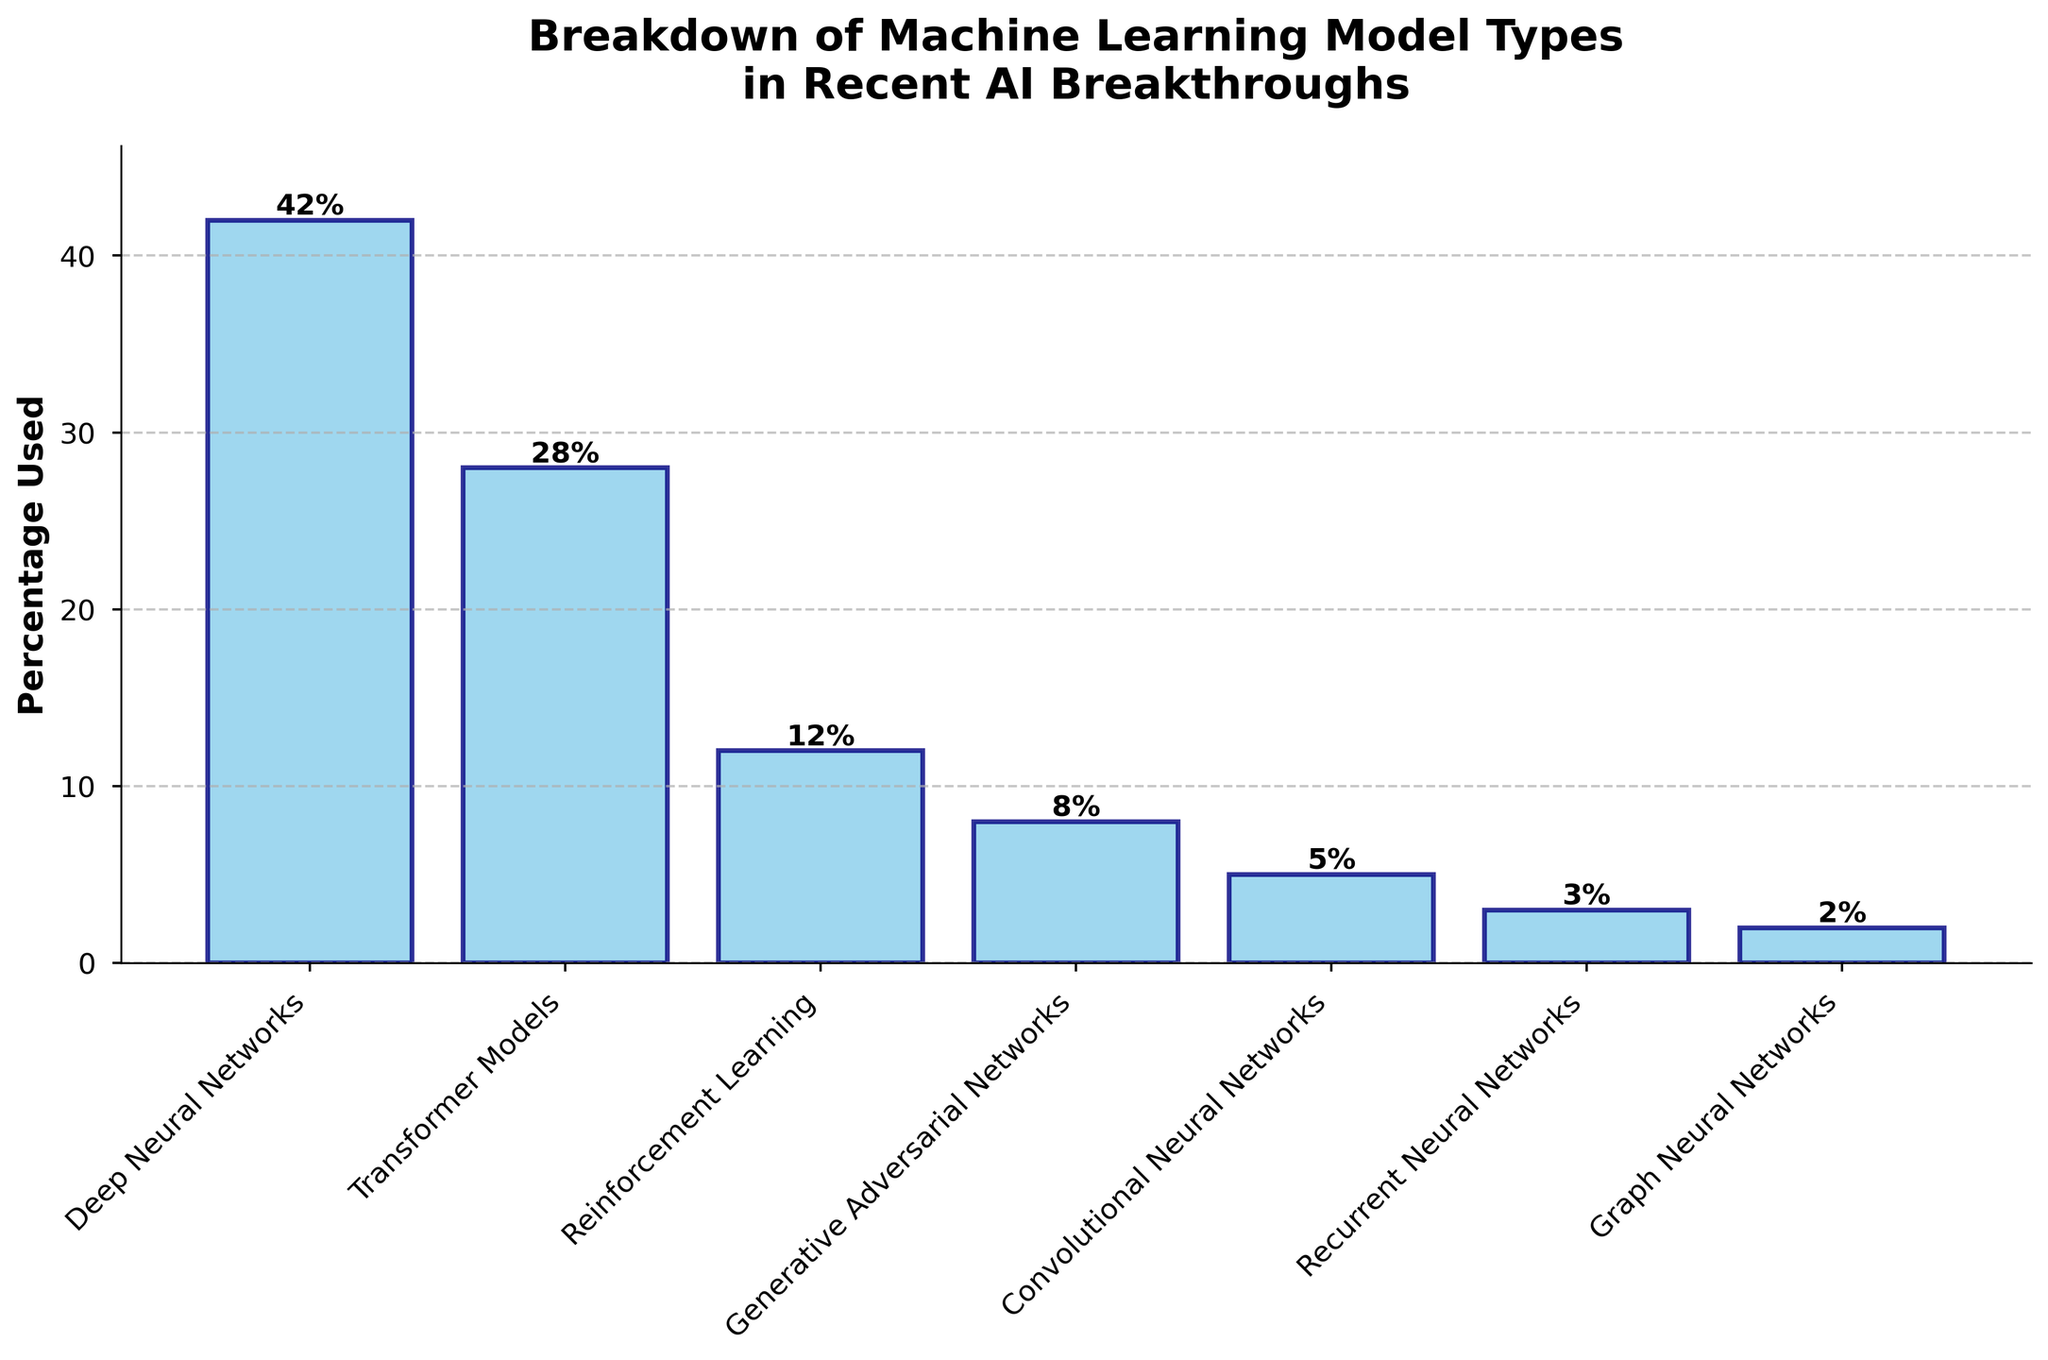What is the most frequently used model type? The height of the bar representing "Deep Neural Networks" is the tallest among all bars, with a value of 42%. Therefore, it is the most frequently used model type.
Answer: Deep Neural Networks Which model type has the closest usage percentage to 10%? The bar height for "Reinforcement Learning" is 12%, which is the closest to 10% compared to other bars.
Answer: Reinforcement Learning How many model types have a usage percentage above 20%? By examining the heights of the bars, only "Deep Neural Networks" (42%) and "Transformer Models" (28%) have usage percentages above 20%.
Answer: 2 What is the combined usage percentage of Generative Adversarial Networks and Convolutional Neural Networks? The bar heights are 8% for Generative Adversarial Networks and 5% for Convolutional Neural Networks. Adding these values gives 8% + 5% = 13%.
Answer: 13% Which model type has the second highest usage percentage and what is its value? The bar representing "Transformer Models" has the second highest height, with a value of 28%.
Answer: Transformer Models, 28% How much higher is the usage percentage of Deep Neural Networks compared to Graph Neural Networks? The bar height for "Deep Neural Networks" is 42%, and for "Graph Neural Networks," it is 2%. Subtracting these values gives 42% - 2% = 40%.
Answer: 40% Which model types have usage percentages lower than 10%? The bars representing "Generative Adversarial Networks" (8%), "Convolutional Neural Networks" (5%), "Recurrent Neural Networks" (3%), and "Graph Neural Networks" (2%) are all below 10%.
Answer: Generative Adversarial Networks, Convolutional Neural Networks, Recurrent Neural Networks, Graph Neural Networks Among “Recurrent Neural Networks” and “Graph Neural Networks”, which has a lower usage percentage and what is the percentage? Comparing the bar heights, "Graph Neural Networks" has a lower usage percentage at 2%, while "Recurrent Neural Networks" is at 3%.
Answer: Graph Neural Networks, 2% Calculate the average usage percentage of all model types. Adding all the usage percentages: 42% (Deep Neural Networks) + 28% (Transformer Models) + 12% (Reinforcement Learning) + 8% (Generative Adversarial Networks) + 5% (Convolutional Neural Networks) + 3% (Recurrent Neural Networks) + 2% (Graph Neural Networks) = 100%. Dividing by 7 model types gives 100% / 7 ≈ 14.29%.
Answer: 14.29% What is the range of usage percentages across all model types? The highest bar height is for "Deep Neural Networks" (42%) and the lowest is for "Graph Neural Networks" (2%). Subtracting these values gives 42% - 2% = 40%.
Answer: 40% 